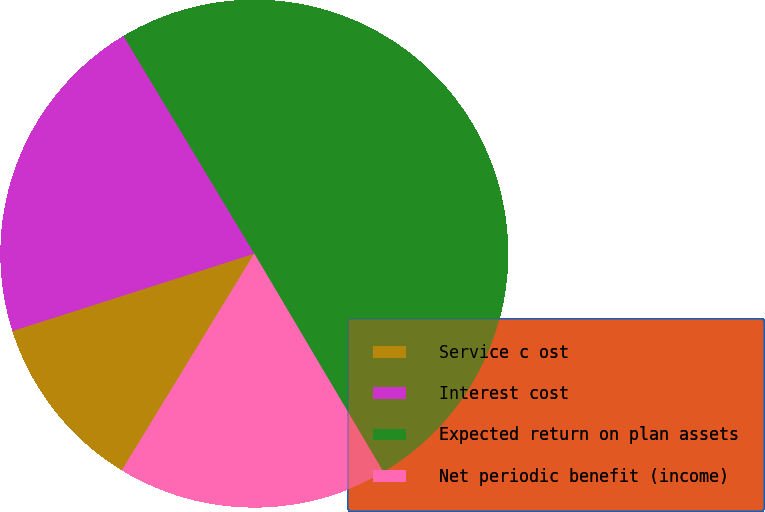Convert chart to OTSL. <chart><loc_0><loc_0><loc_500><loc_500><pie_chart><fcel>Service c ost<fcel>Interest cost<fcel>Expected return on plan assets<fcel>Net periodic benefit (income)<nl><fcel>11.34%<fcel>21.32%<fcel>50.11%<fcel>17.23%<nl></chart> 